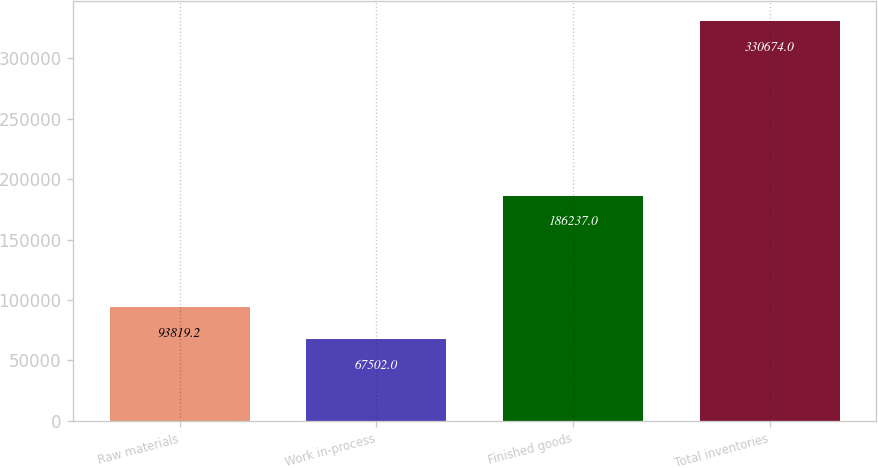Convert chart. <chart><loc_0><loc_0><loc_500><loc_500><bar_chart><fcel>Raw materials<fcel>Work in-process<fcel>Finished goods<fcel>Total inventories<nl><fcel>93819.2<fcel>67502<fcel>186237<fcel>330674<nl></chart> 